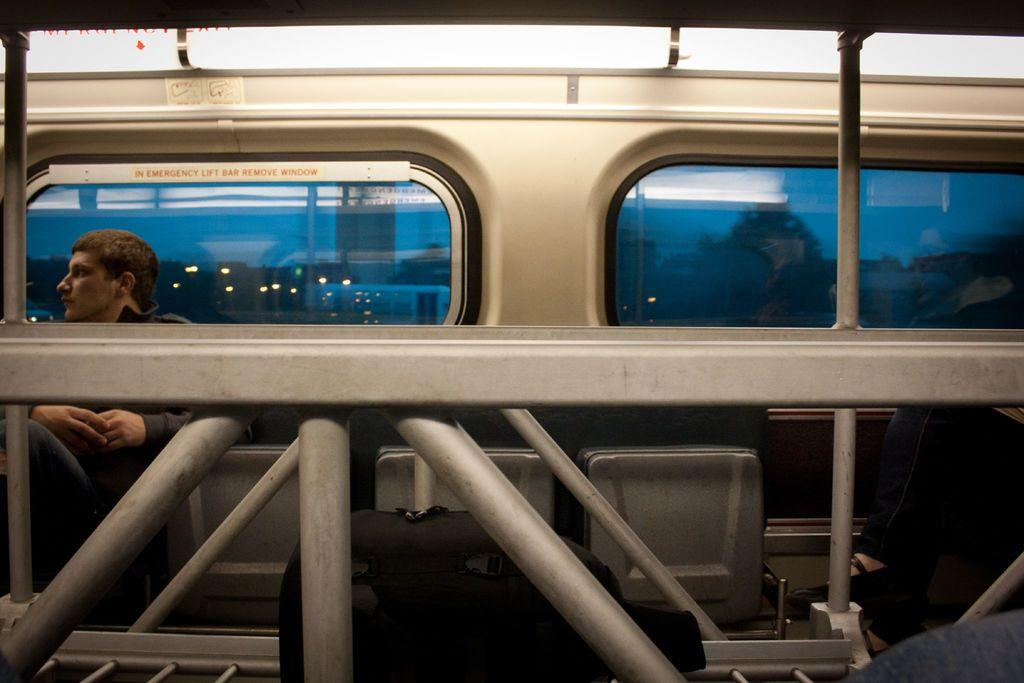What type of structure is visible in the image? There are iron grills and windows visible in the image, which suggests a building or enclosed area. What are the people in the image doing? There are persons sitting on chairs in the image, indicating that they might be resting or engaged in conversation. What type of information might be conveyed by the sign boards in the image? The sign boards in the image could provide directions, advertisements, or other important information. Can you see any farm animals in the image? There are no farm animals present in the image. What type of beam is holding up the roof in the image? There is no roof or beam visible in the image; it only shows iron grills, windows, persons sitting on chairs, and sign boards. 